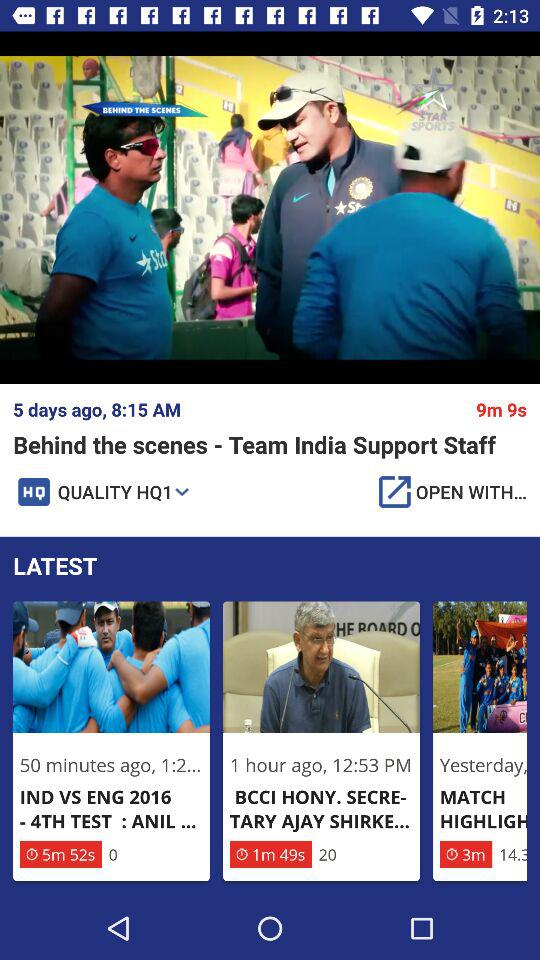What is the publication time of the IND vs ENG 2016-4th test? The publication time was 50 minutes ago. 